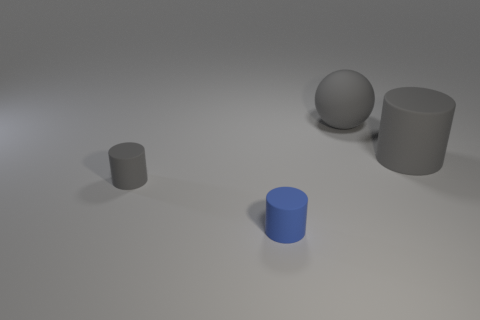Subtract all tiny blue matte cylinders. How many cylinders are left? 2 Add 1 small blue matte cylinders. How many objects exist? 5 Subtract all blue spheres. How many gray cylinders are left? 2 Subtract all blue cylinders. How many cylinders are left? 2 Subtract all cylinders. How many objects are left? 1 Subtract 1 spheres. How many spheres are left? 0 Subtract all small brown metallic cubes. Subtract all spheres. How many objects are left? 3 Add 4 spheres. How many spheres are left? 5 Add 2 tiny gray matte objects. How many tiny gray matte objects exist? 3 Subtract 2 gray cylinders. How many objects are left? 2 